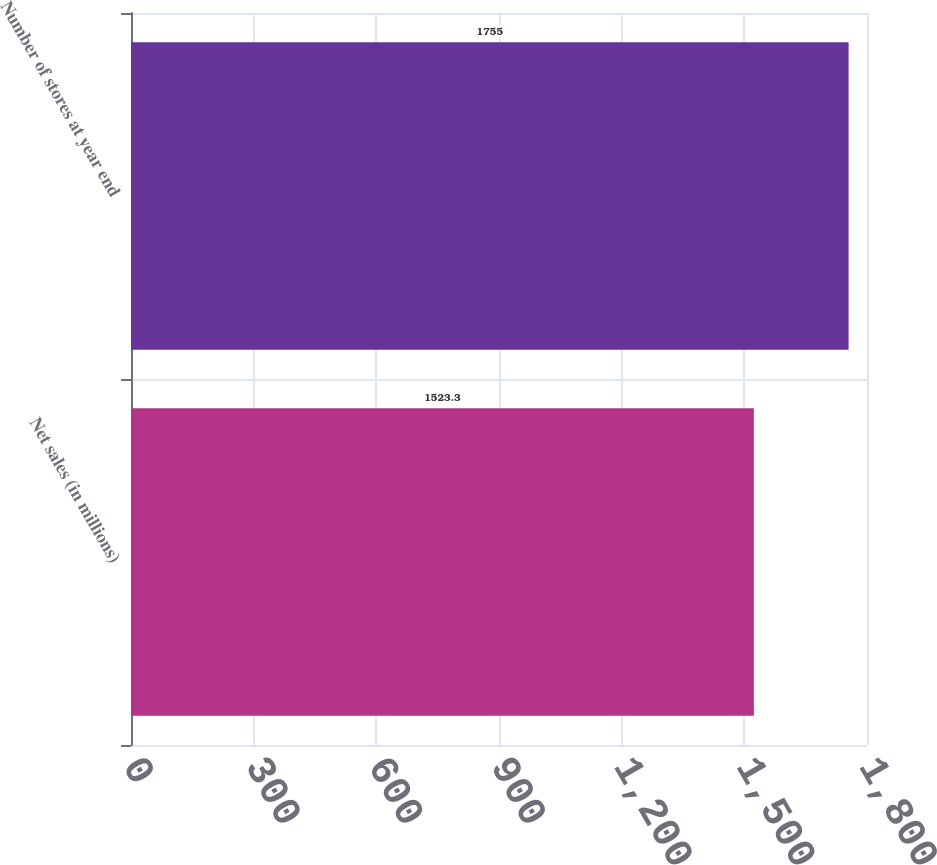Convert chart. <chart><loc_0><loc_0><loc_500><loc_500><bar_chart><fcel>Net sales (in millions)<fcel>Number of stores at year end<nl><fcel>1523.3<fcel>1755<nl></chart> 